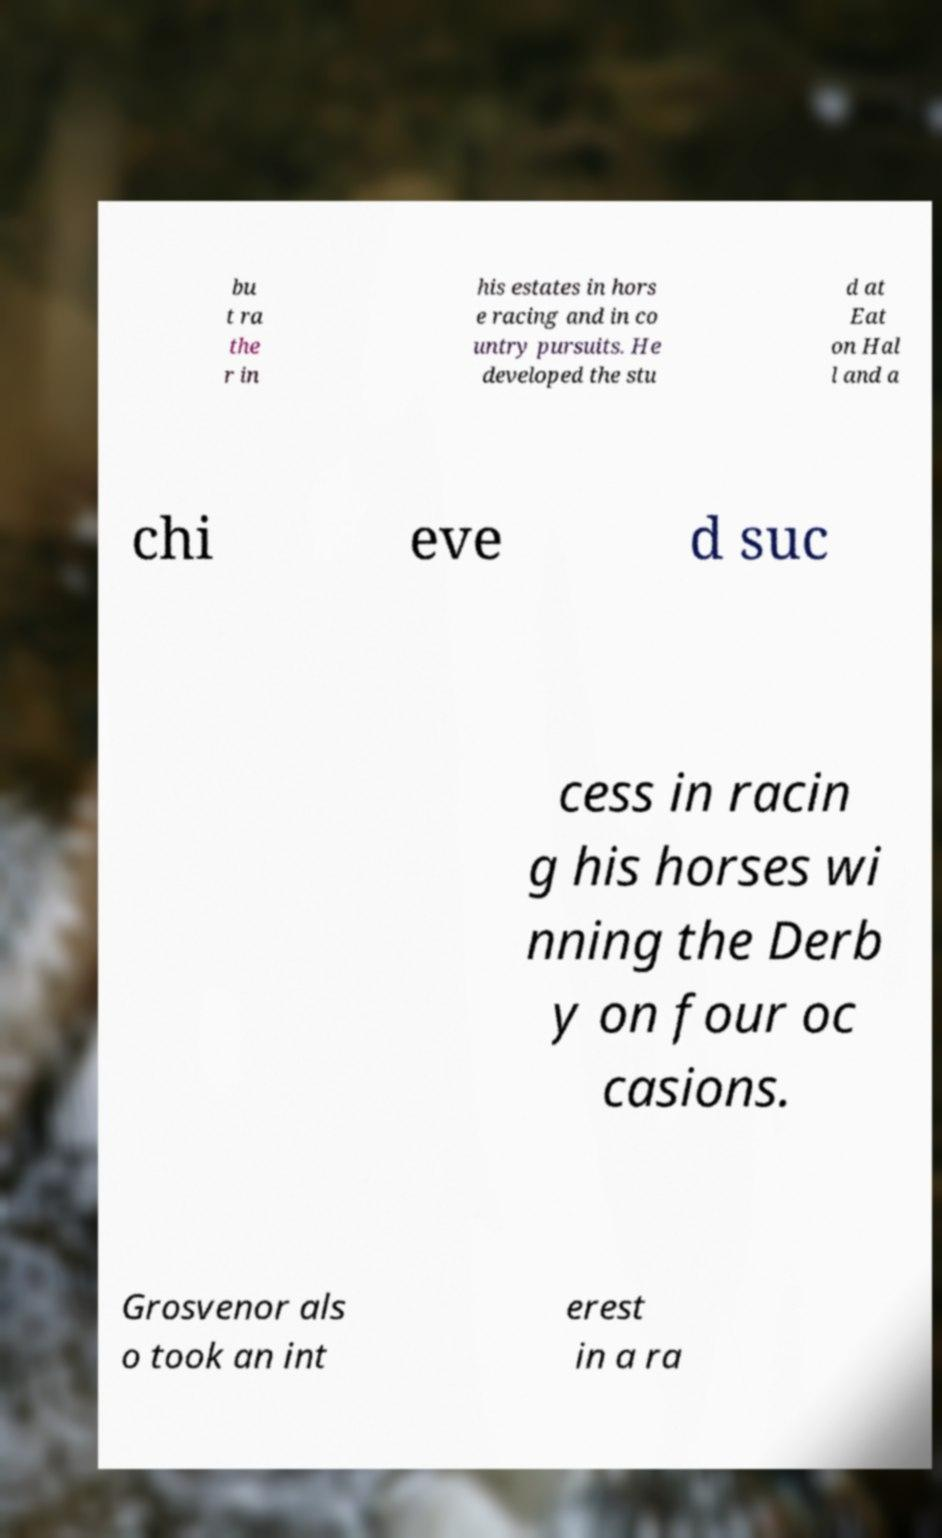For documentation purposes, I need the text within this image transcribed. Could you provide that? bu t ra the r in his estates in hors e racing and in co untry pursuits. He developed the stu d at Eat on Hal l and a chi eve d suc cess in racin g his horses wi nning the Derb y on four oc casions. Grosvenor als o took an int erest in a ra 